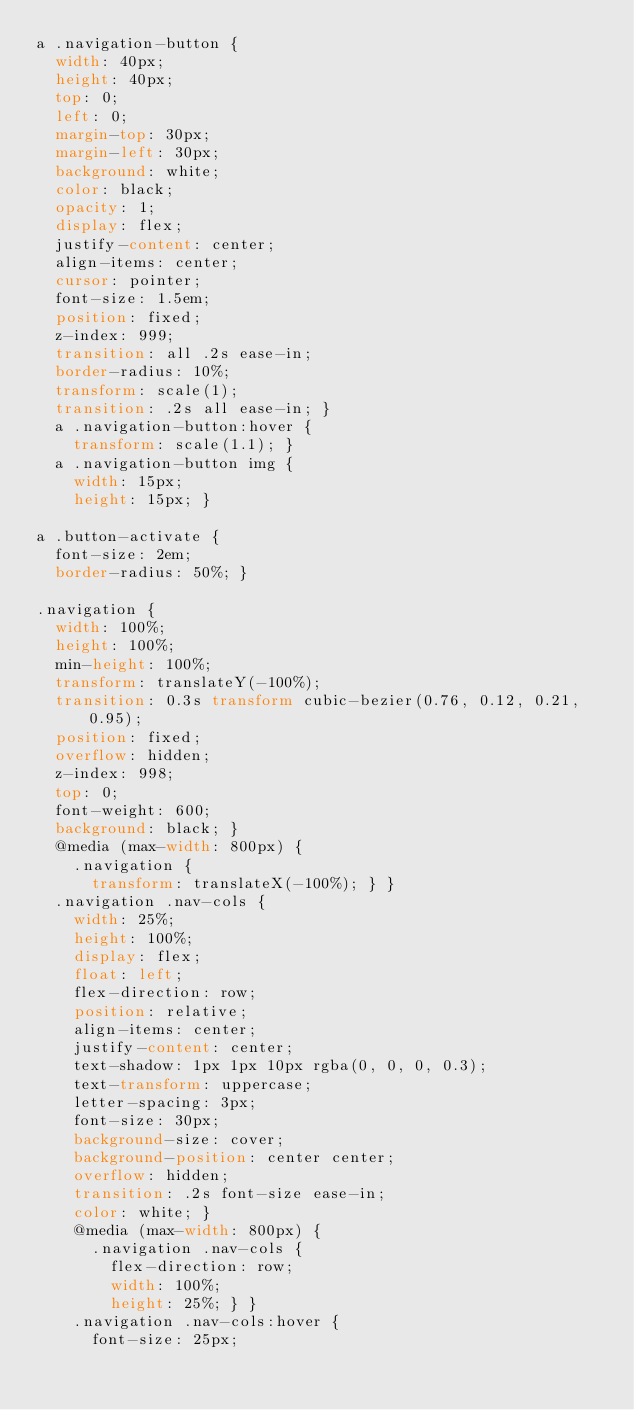Convert code to text. <code><loc_0><loc_0><loc_500><loc_500><_CSS_>a .navigation-button {
  width: 40px;
  height: 40px;
  top: 0;
  left: 0;
  margin-top: 30px;
  margin-left: 30px;
  background: white;
  color: black;
  opacity: 1;
  display: flex;
  justify-content: center;
  align-items: center;
  cursor: pointer;
  font-size: 1.5em;
  position: fixed;
  z-index: 999;
  transition: all .2s ease-in;
  border-radius: 10%;
  transform: scale(1);
  transition: .2s all ease-in; }
  a .navigation-button:hover {
    transform: scale(1.1); }
  a .navigation-button img {
    width: 15px;
    height: 15px; }

a .button-activate {
  font-size: 2em;
  border-radius: 50%; }

.navigation {
  width: 100%;
  height: 100%;
  min-height: 100%;
  transform: translateY(-100%);
  transition: 0.3s transform cubic-bezier(0.76, 0.12, 0.21, 0.95);
  position: fixed;
  overflow: hidden;
  z-index: 998;
  top: 0;
  font-weight: 600;
  background: black; }
  @media (max-width: 800px) {
    .navigation {
      transform: translateX(-100%); } }
  .navigation .nav-cols {
    width: 25%;
    height: 100%;
    display: flex;
    float: left;
    flex-direction: row;
    position: relative;
    align-items: center;
    justify-content: center;
    text-shadow: 1px 1px 10px rgba(0, 0, 0, 0.3);
    text-transform: uppercase;
    letter-spacing: 3px;
    font-size: 30px;
    background-size: cover;
    background-position: center center;
    overflow: hidden;
    transition: .2s font-size ease-in;
    color: white; }
    @media (max-width: 800px) {
      .navigation .nav-cols {
        flex-direction: row;
        width: 100%;
        height: 25%; } }
    .navigation .nav-cols:hover {
      font-size: 25px;</code> 